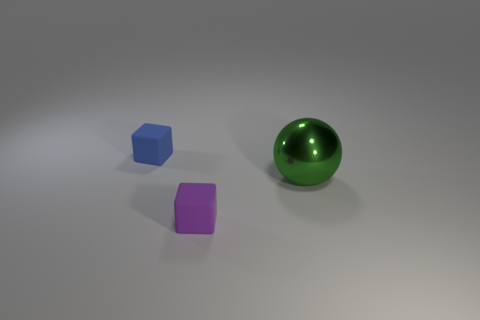Add 1 balls. How many objects exist? 4 Subtract all spheres. How many objects are left? 2 Subtract 0 brown cubes. How many objects are left? 3 Subtract all purple rubber objects. Subtract all small blue blocks. How many objects are left? 1 Add 3 blue cubes. How many blue cubes are left? 4 Add 1 small purple rubber objects. How many small purple rubber objects exist? 2 